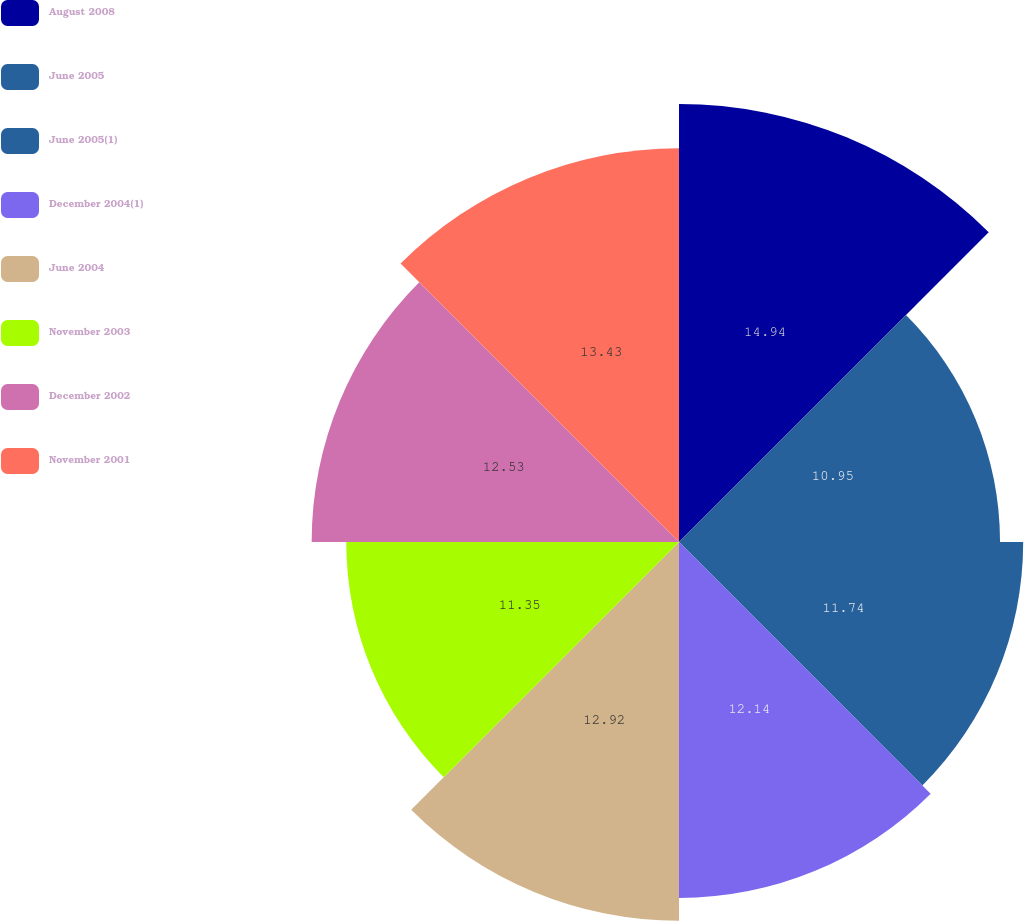Convert chart. <chart><loc_0><loc_0><loc_500><loc_500><pie_chart><fcel>August 2008<fcel>June 2005<fcel>June 2005(1)<fcel>December 2004(1)<fcel>June 2004<fcel>November 2003<fcel>December 2002<fcel>November 2001<nl><fcel>14.94%<fcel>10.95%<fcel>11.74%<fcel>12.14%<fcel>12.92%<fcel>11.35%<fcel>12.53%<fcel>13.43%<nl></chart> 